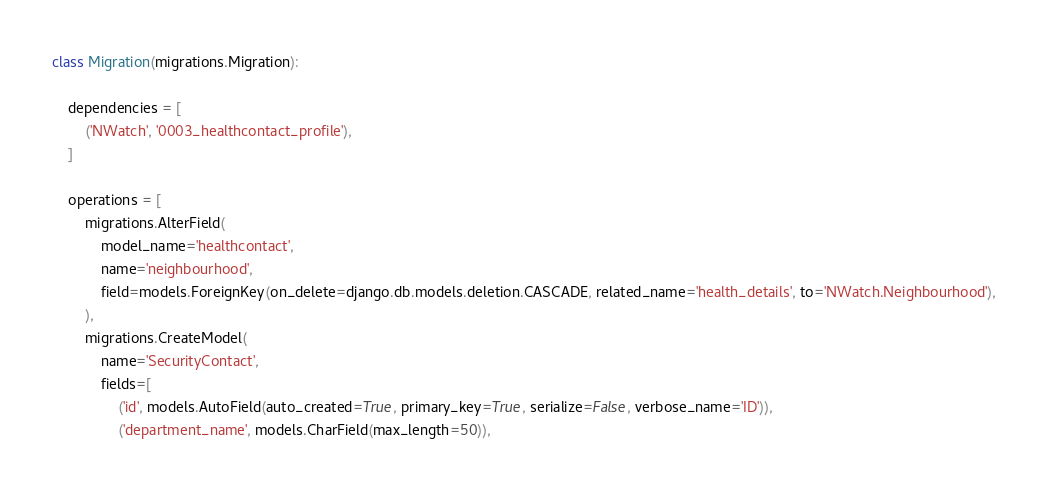Convert code to text. <code><loc_0><loc_0><loc_500><loc_500><_Python_>
class Migration(migrations.Migration):

    dependencies = [
        ('NWatch', '0003_healthcontact_profile'),
    ]

    operations = [
        migrations.AlterField(
            model_name='healthcontact',
            name='neighbourhood',
            field=models.ForeignKey(on_delete=django.db.models.deletion.CASCADE, related_name='health_details', to='NWatch.Neighbourhood'),
        ),
        migrations.CreateModel(
            name='SecurityContact',
            fields=[
                ('id', models.AutoField(auto_created=True, primary_key=True, serialize=False, verbose_name='ID')),
                ('department_name', models.CharField(max_length=50)),</code> 